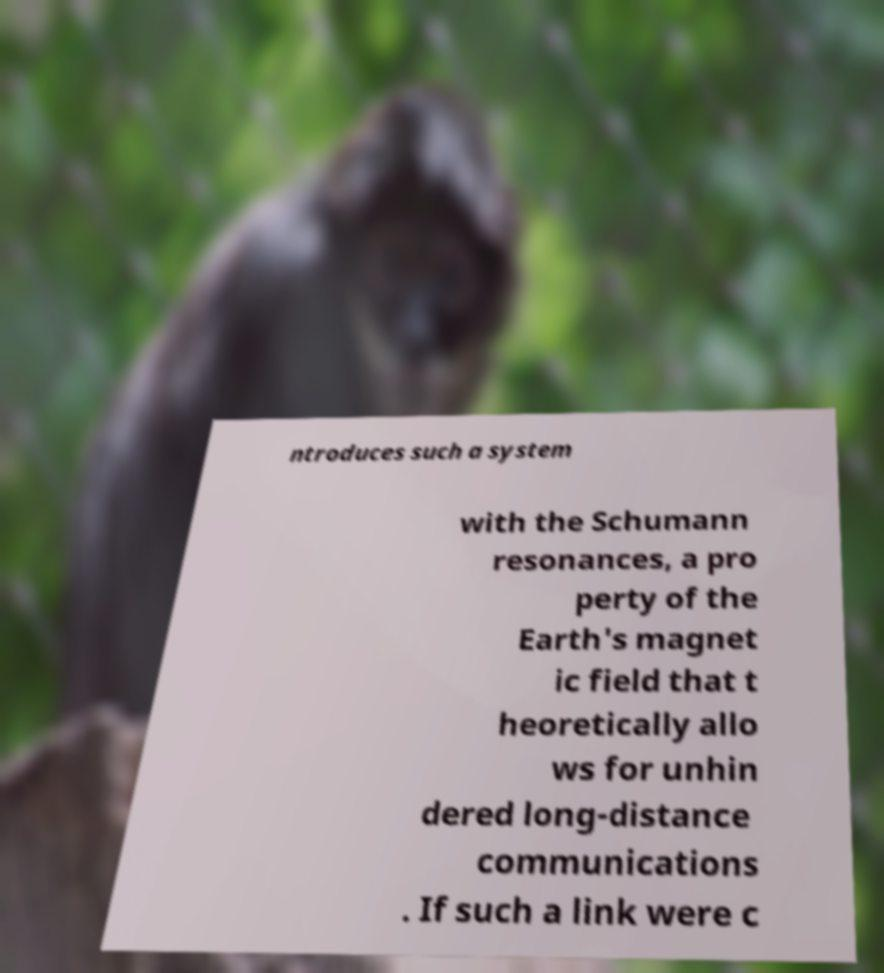Please identify and transcribe the text found in this image. ntroduces such a system with the Schumann resonances, a pro perty of the Earth's magnet ic field that t heoretically allo ws for unhin dered long-distance communications . If such a link were c 